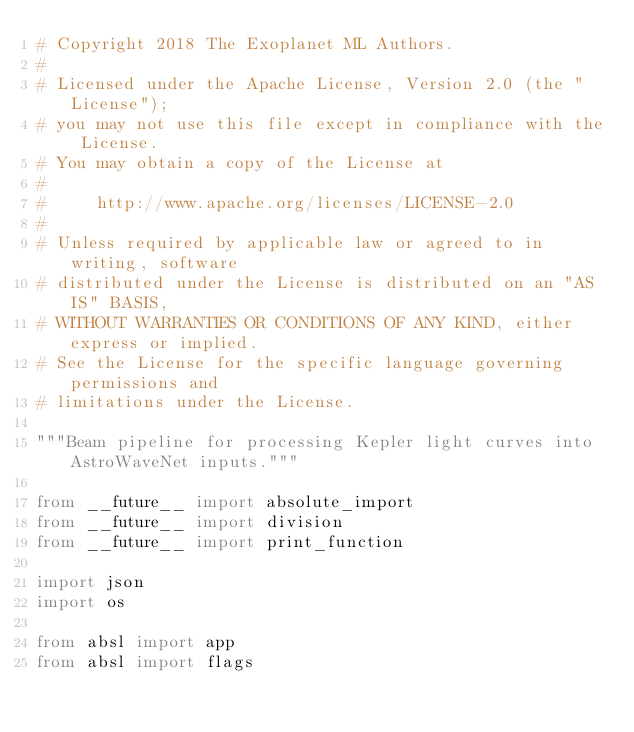Convert code to text. <code><loc_0><loc_0><loc_500><loc_500><_Python_># Copyright 2018 The Exoplanet ML Authors.
#
# Licensed under the Apache License, Version 2.0 (the "License");
# you may not use this file except in compliance with the License.
# You may obtain a copy of the License at
#
#     http://www.apache.org/licenses/LICENSE-2.0
#
# Unless required by applicable law or agreed to in writing, software
# distributed under the License is distributed on an "AS IS" BASIS,
# WITHOUT WARRANTIES OR CONDITIONS OF ANY KIND, either express or implied.
# See the License for the specific language governing permissions and
# limitations under the License.

"""Beam pipeline for processing Kepler light curves into AstroWaveNet inputs."""

from __future__ import absolute_import
from __future__ import division
from __future__ import print_function

import json
import os

from absl import app
from absl import flags</code> 